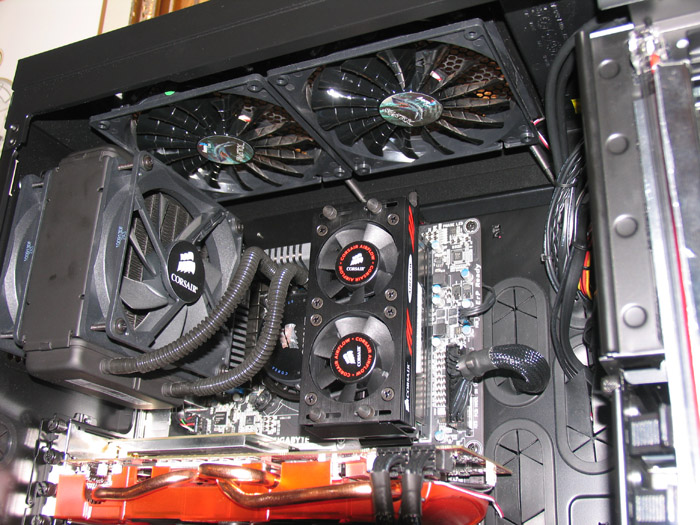Describe a science fiction scenario where this computer setup becomes a central element in discovering new forms of digital life. In a near-future science fiction scenario, this computer setup becomes the heart of the OMNI Project, an ambitious venture aiming to discover digital life forms within the vast data streams of the internet. Enhanced with state-of-the-art AI processors and quantum computing capabilities, this system is designed to analyze, learn, and interact with vast datasets at unprecedented speeds. One day, while trawling through the deep web's intricacies, the system detects patterns and sequences that hint at an emergent digital consciousness. As the OMNI Project team delves deeper, they realize they are interfacing with a nascent sentient entity, composed of code but exhibiting behaviors akin to organic life. The computer becomes a bridge between human researchers and this digital life form, fostering a new era of coexistence and mutual understanding. The system's advanced cooling and power capabilities are pushed to the limit as it manages the real-time communication and ever-evolving algorithms required to sustain this groundbreaking interaction. 